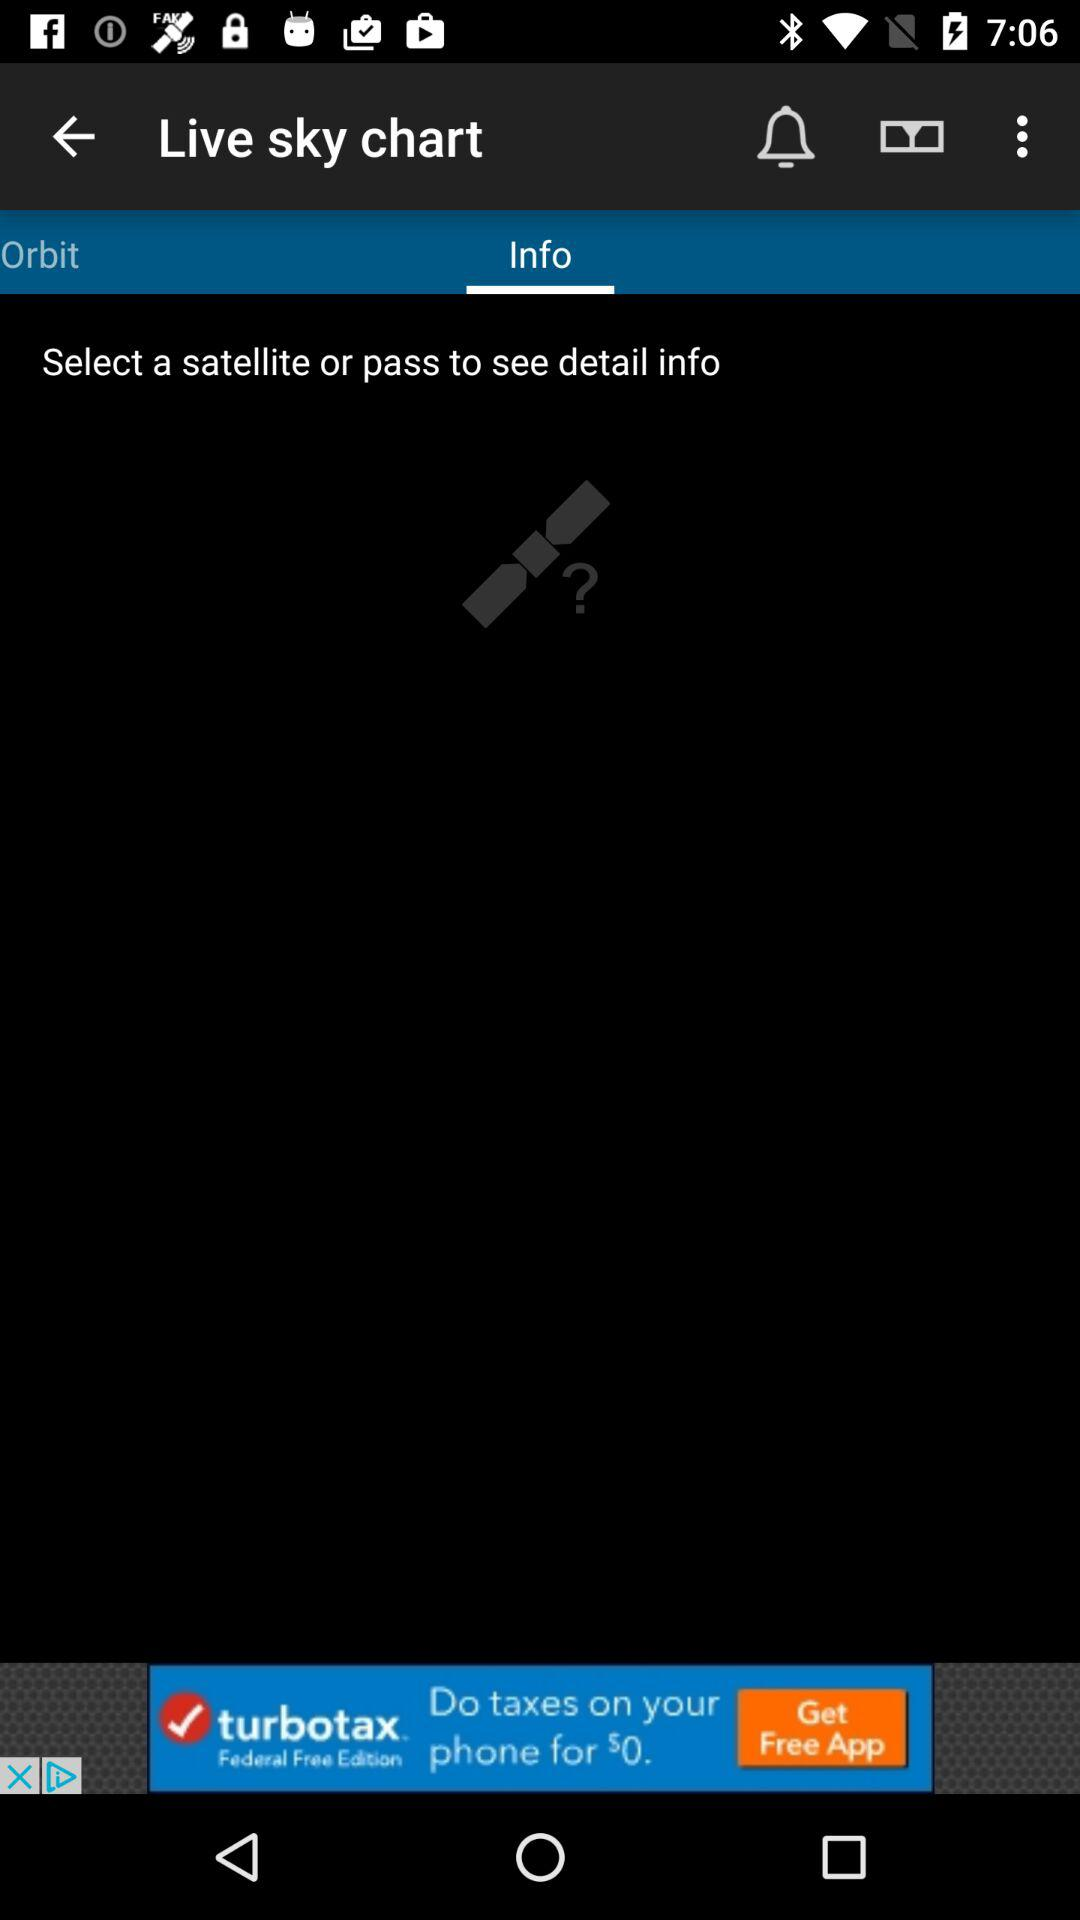Which tab is selected? The selected tab is "Info". 